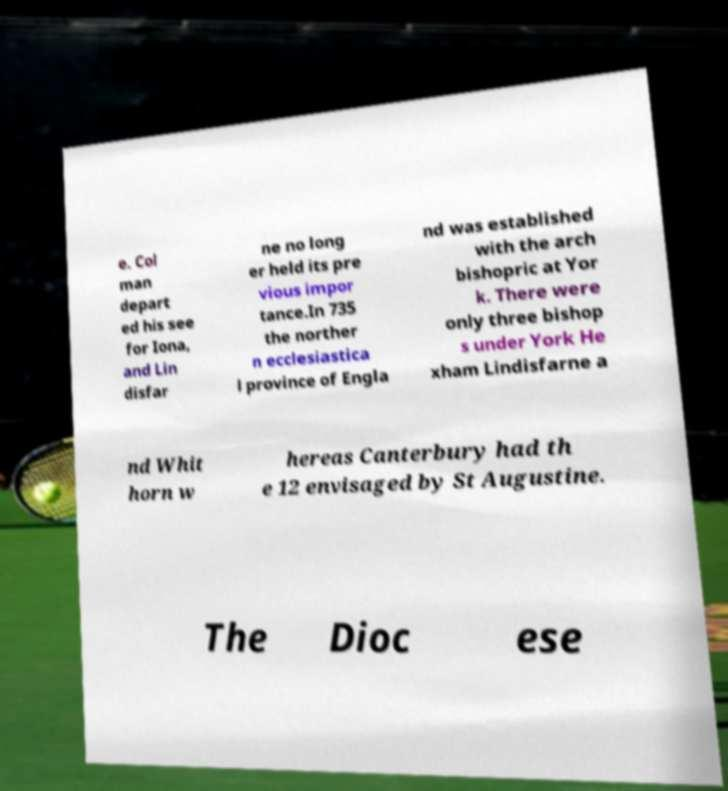Please read and relay the text visible in this image. What does it say? e. Col man depart ed his see for Iona, and Lin disfar ne no long er held its pre vious impor tance.In 735 the norther n ecclesiastica l province of Engla nd was established with the arch bishopric at Yor k. There were only three bishop s under York He xham Lindisfarne a nd Whit horn w hereas Canterbury had th e 12 envisaged by St Augustine. The Dioc ese 